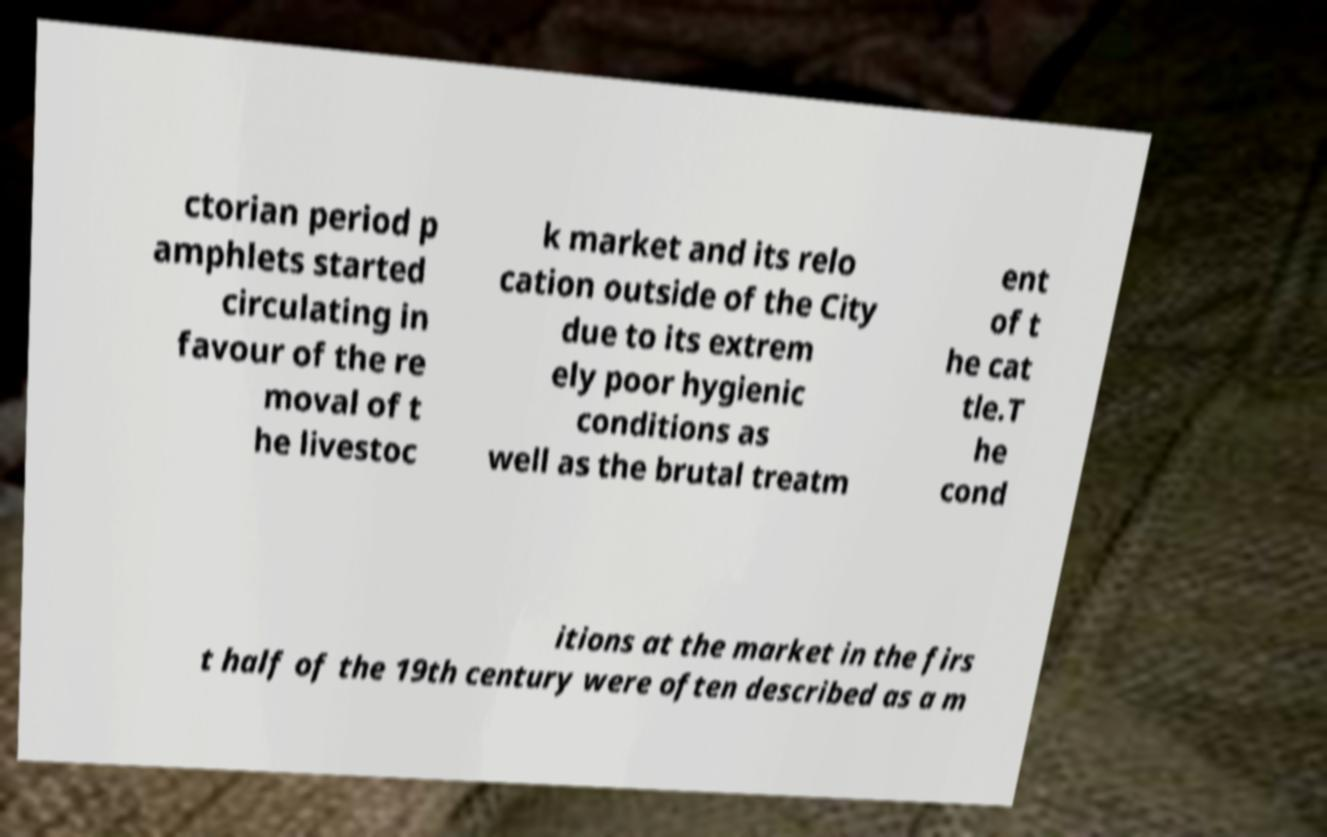Can you accurately transcribe the text from the provided image for me? ctorian period p amphlets started circulating in favour of the re moval of t he livestoc k market and its relo cation outside of the City due to its extrem ely poor hygienic conditions as well as the brutal treatm ent of t he cat tle.T he cond itions at the market in the firs t half of the 19th century were often described as a m 